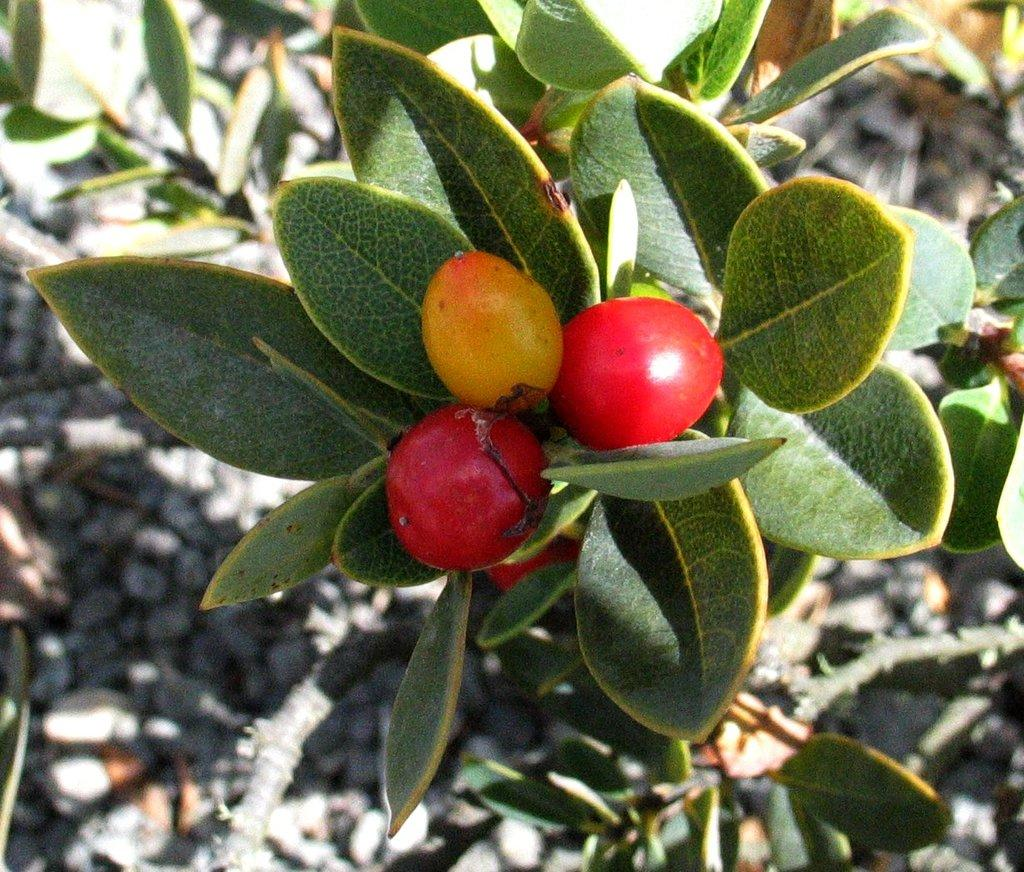What type of plants can be seen in the front of the image? There are vegetables, leaves, and stems visible in the front of the image. What can be observed about the background of the image? The background of the image is blurry. What language are the fairies speaking in the image? There are no fairies present in the image, so it is not possible to determine what language they might be speaking. 